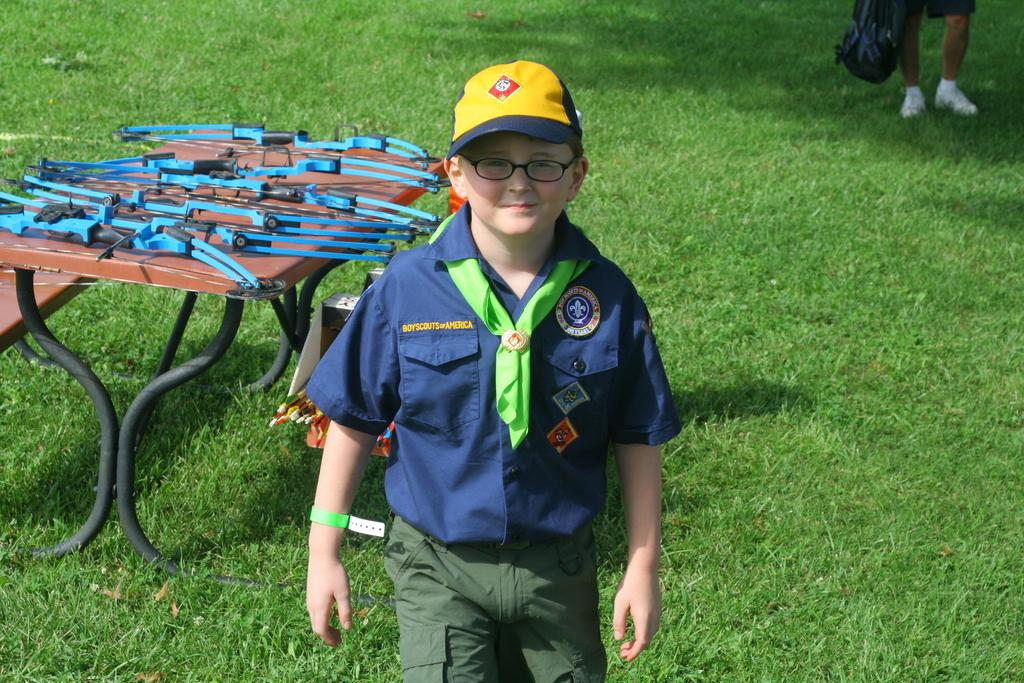Who is in the image? There is a boy in the image. What is the boy doing in the image? The boy is standing in the image. What accessories is the boy wearing? The boy is wearing a cap on his head and spectacles on his face. What type of vegetation can be seen in the image? There is green grass in the image. What objects are on the bench in the image? There are bows on a bench in the image. What type of mitten is the boy wearing on his hand in the image? There is no mitten visible on the boy's hand in the image. How many wheels can be seen on the bench in the image? There are no wheels present on the bench or any other object in the image. 